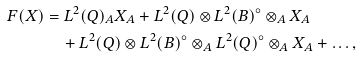<formula> <loc_0><loc_0><loc_500><loc_500>F ( X ) & = L ^ { 2 } ( Q ) _ { A } X _ { A } + L ^ { 2 } ( Q ) \otimes L ^ { 2 } ( B ) ^ { \circ } \otimes _ { A } X _ { A } \\ & \quad + L ^ { 2 } ( Q ) \otimes L ^ { 2 } ( B ) ^ { \circ } \otimes _ { A } L ^ { 2 } ( Q ) ^ { \circ } \otimes _ { A } X _ { A } + \dots ,</formula> 